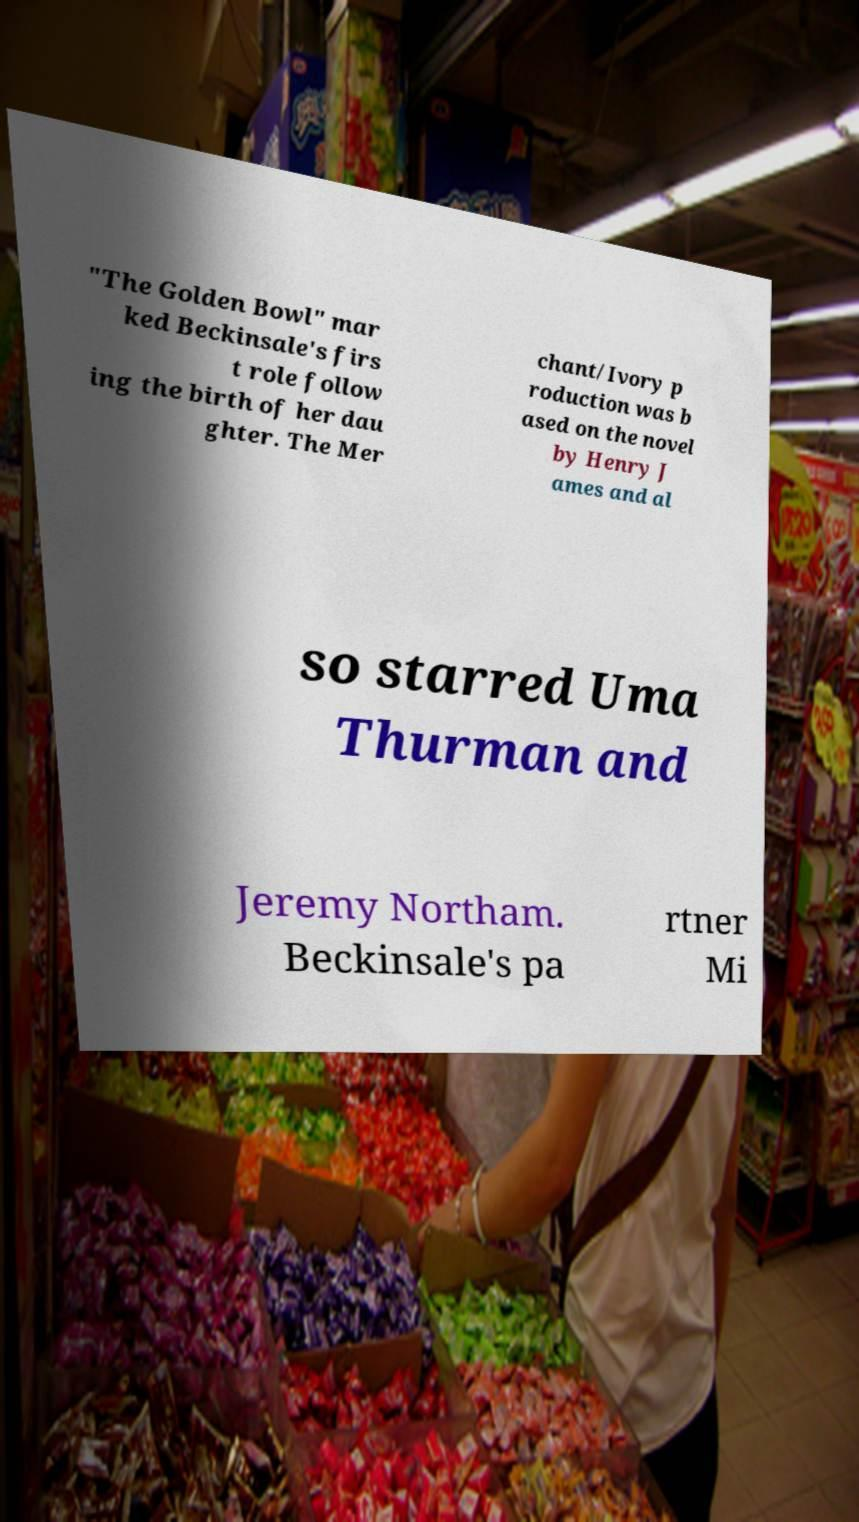Can you read and provide the text displayed in the image?This photo seems to have some interesting text. Can you extract and type it out for me? "The Golden Bowl" mar ked Beckinsale's firs t role follow ing the birth of her dau ghter. The Mer chant/Ivory p roduction was b ased on the novel by Henry J ames and al so starred Uma Thurman and Jeremy Northam. Beckinsale's pa rtner Mi 